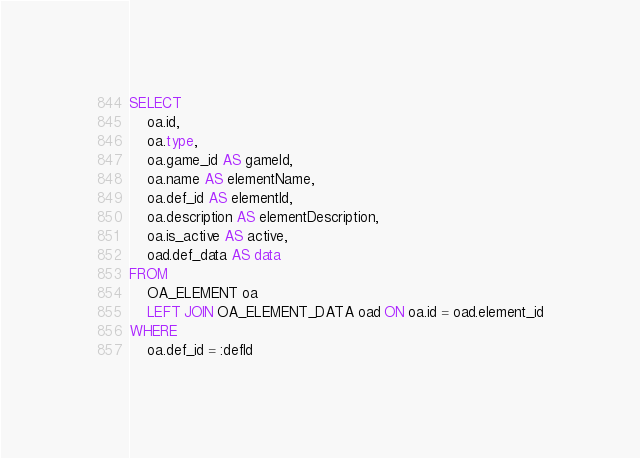Convert code to text. <code><loc_0><loc_0><loc_500><loc_500><_SQL_>SELECT
    oa.id,
    oa.type,
    oa.game_id AS gameId,
    oa.name AS elementName,
    oa.def_id AS elementId,
    oa.description AS elementDescription,
    oa.is_active AS active,
    oad.def_data AS data
FROM
    OA_ELEMENT oa
    LEFT JOIN OA_ELEMENT_DATA oad ON oa.id = oad.element_id
WHERE
    oa.def_id = :defId</code> 